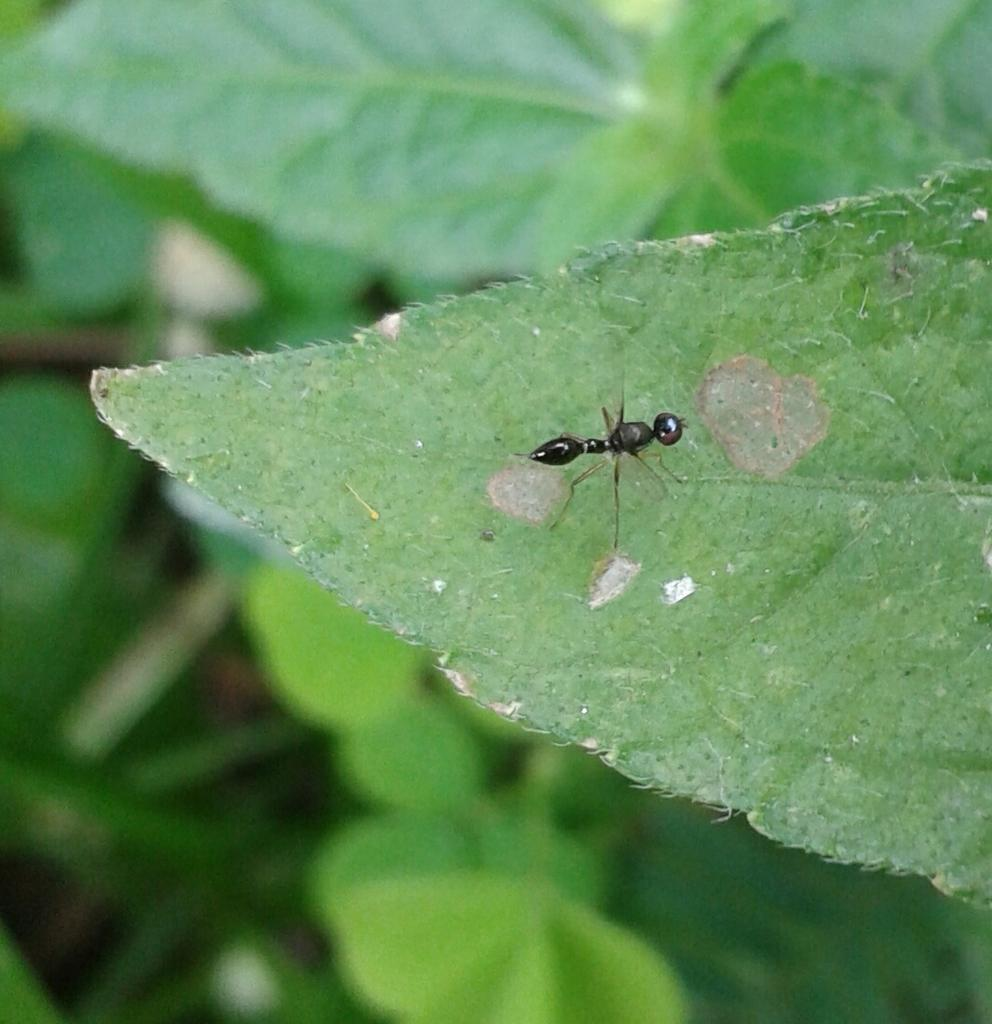What is the main subject of the image? The main subject of the image is an ant. Where is the ant located in the image? The ant is on a leaf. What type of music is the ant playing on the horn in the image? There is no horn or music present in the image; it features an ant on a leaf. 